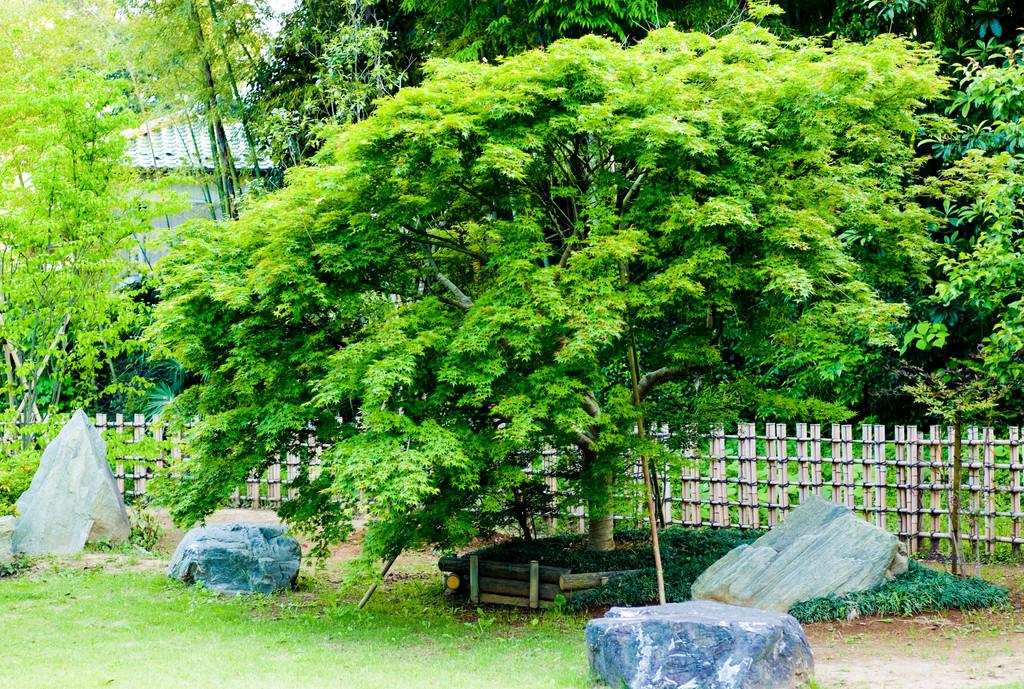What type of terrain is depicted in the image? The image shows rocks and grass on the ground. What is the wooden structure behind the rocks? There is a wooden fencing behind the rocks. What can be seen in the background of the image? There are trees and a house in the background of the image. What is visible at the top of the image? The sky is visible at the top of the image. Where is the plate of food located in the image? There is no plate of food present in the image. How many mice can be seen running around in the image? There are no mice present in the image. 